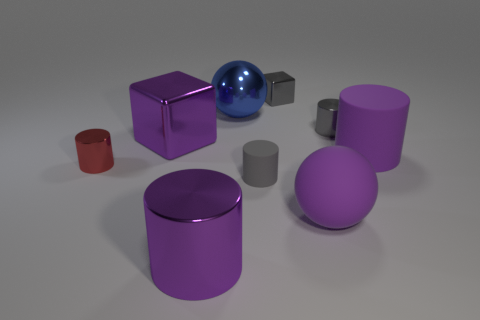Subtract all shiny cylinders. How many cylinders are left? 2 Subtract all purple cylinders. How many cylinders are left? 3 Subtract all spheres. How many objects are left? 7 Subtract 2 balls. How many balls are left? 0 Subtract all blue spheres. Subtract all cyan cylinders. How many spheres are left? 1 Subtract all purple spheres. How many red cubes are left? 0 Subtract all large yellow shiny blocks. Subtract all small gray metallic things. How many objects are left? 7 Add 5 purple matte cylinders. How many purple matte cylinders are left? 6 Add 7 small matte objects. How many small matte objects exist? 8 Subtract 0 green cylinders. How many objects are left? 9 